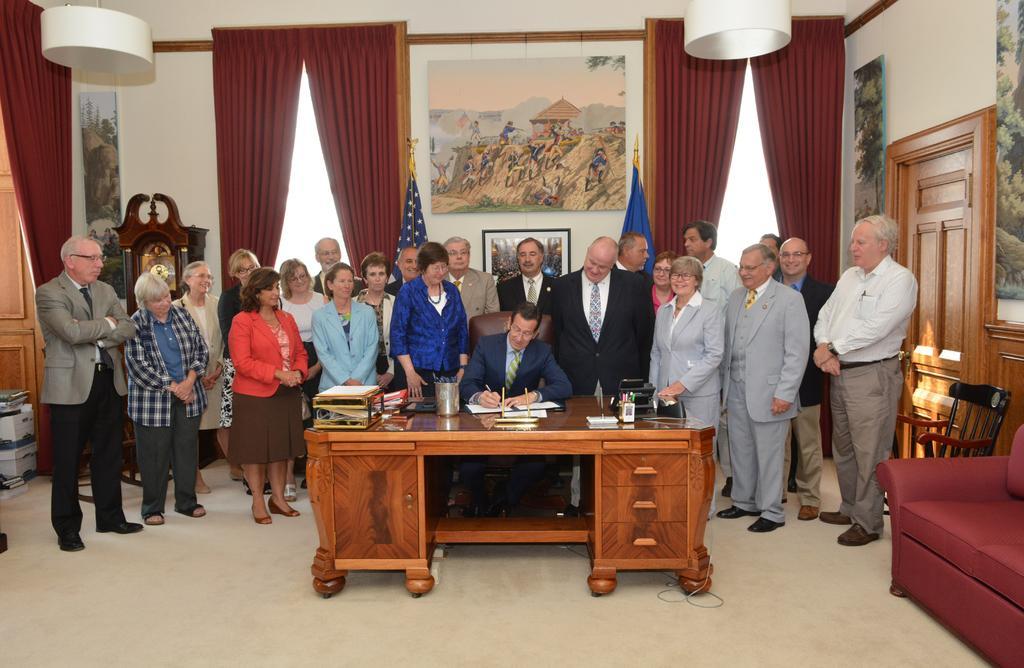Can you describe this image briefly? In this image I can see the group of people standing. Among them one person is sitting and writing something. In front of him there is a table with books on it. At the back side there is a board and curtains attached to the wall. 